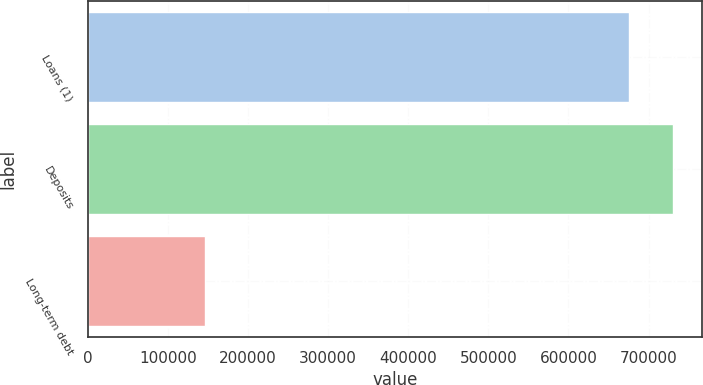Convert chart to OTSL. <chart><loc_0><loc_0><loc_500><loc_500><bar_chart><fcel>Loans (1)<fcel>Deposits<fcel>Long-term debt<nl><fcel>675544<fcel>730294<fcel>146000<nl></chart> 